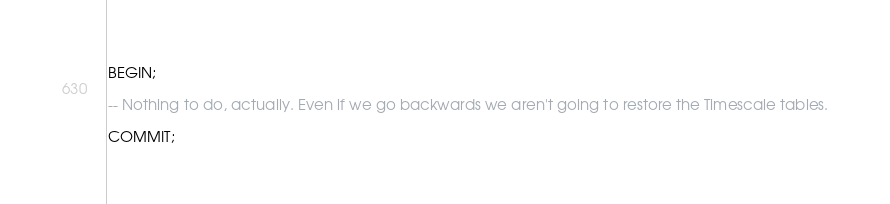<code> <loc_0><loc_0><loc_500><loc_500><_SQL_>BEGIN;

-- Nothing to do, actually. Even if we go backwards we aren't going to restore the Timescale tables.

COMMIT;
</code> 